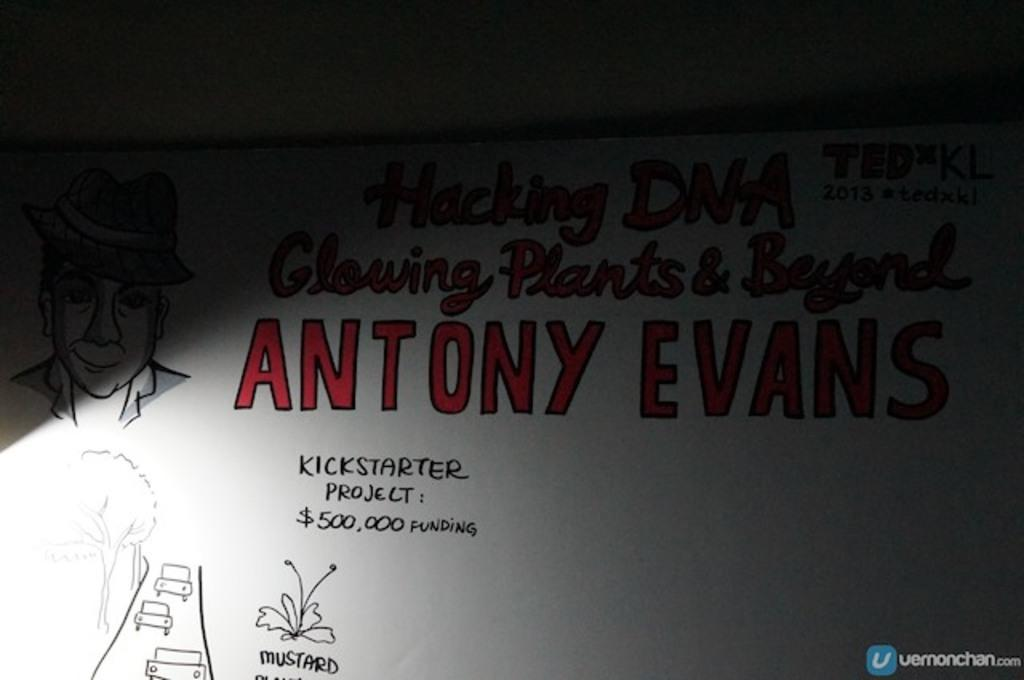What type of image is being described? The image is a drawing. What can be seen on the left side of the drawing? There is a drawing of a person on the left side of the image. What is located at the center of the image? There is text at the center of the image. What type of badge is the person wearing in the image? There is no badge visible in the image; it is a drawing of a person without any accessories. What grade does the person receive for their drawing in the image? There is no indication of a grade or evaluation in the image; it is simply a drawing with a person and text. 